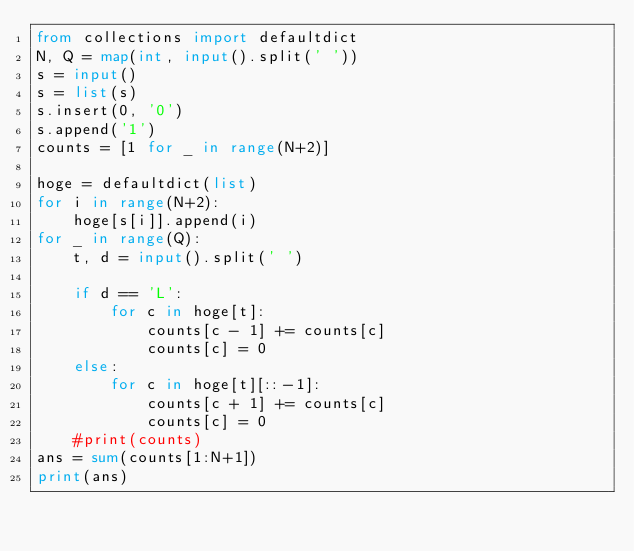Convert code to text. <code><loc_0><loc_0><loc_500><loc_500><_Python_>from collections import defaultdict
N, Q = map(int, input().split(' '))
s = input()
s = list(s)
s.insert(0, '0')
s.append('1')
counts = [1 for _ in range(N+2)]

hoge = defaultdict(list)
for i in range(N+2):
    hoge[s[i]].append(i)
for _ in range(Q):
    t, d = input().split(' ')
    
    if d == 'L':
        for c in hoge[t]:
            counts[c - 1] += counts[c]
            counts[c] = 0
    else:
        for c in hoge[t][::-1]:
            counts[c + 1] += counts[c]
            counts[c] = 0
    #print(counts)
ans = sum(counts[1:N+1])
print(ans)

    
</code> 